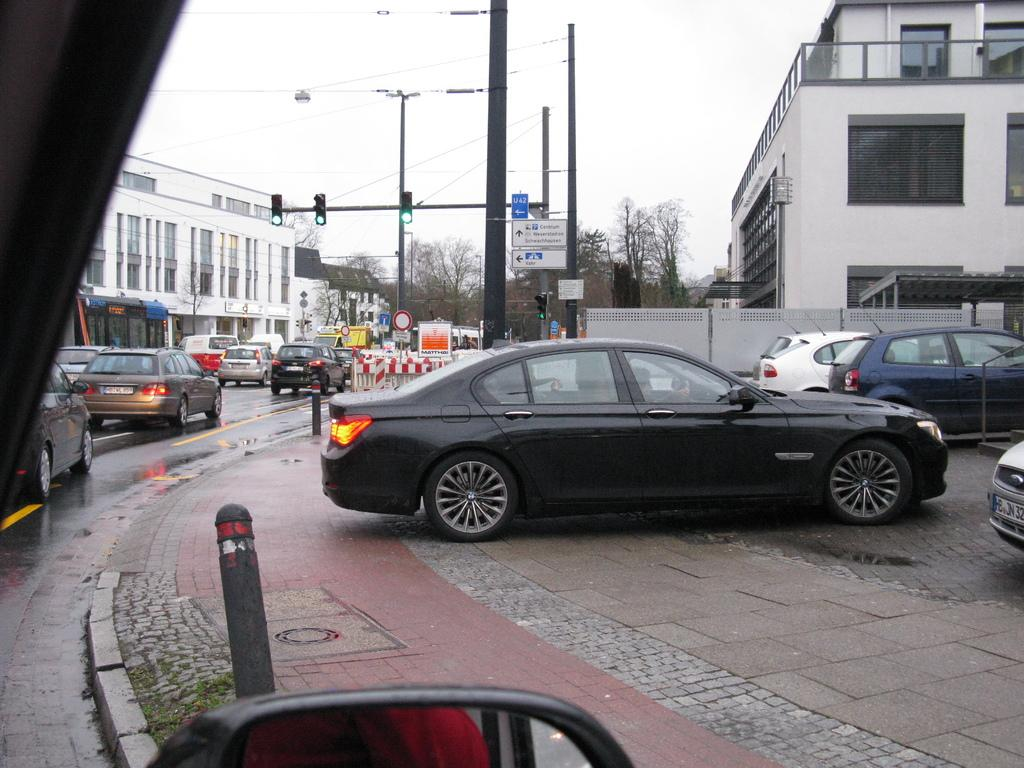What type of structures can be seen in the image? There are electric poles, traffic poles, traffic signals, and buildings in the image. What type of transportation is visible on the road? There are motor vehicles on the road in the image. What type of path is available for pedestrians? There is a footpath in the image. What type of vegetation is present in the image? There are trees in the image. What is visible in the sky? The sky is visible in the image. What type of grape is being used as a traffic signal in the image? There is no grape being used as a traffic signal in the image; the traffic signals are electronic devices. What scene is being depicted in the image? The image is not a scene; it is a photograph of a real-life urban setting with electric poles, traffic poles, traffic signals, motor vehicles, a footpath, buildings, trees, and the sky. 